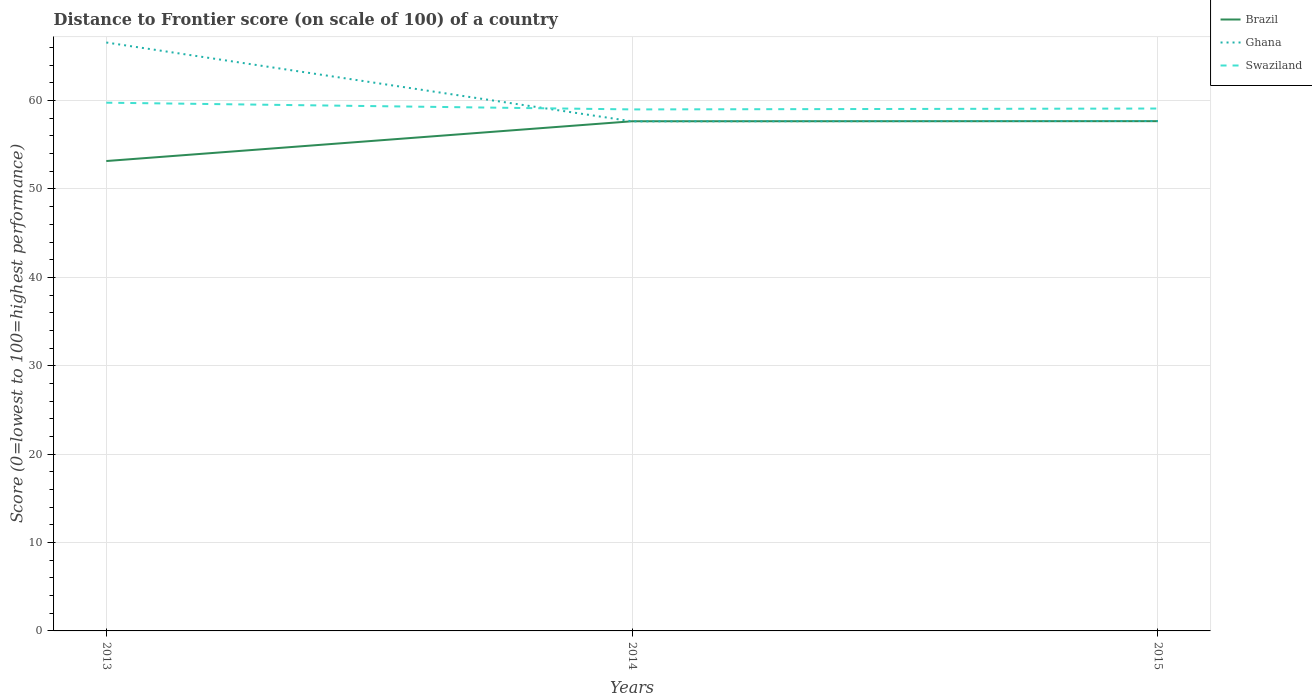How many different coloured lines are there?
Ensure brevity in your answer.  3. Does the line corresponding to Ghana intersect with the line corresponding to Swaziland?
Offer a very short reply. Yes. Is the number of lines equal to the number of legend labels?
Provide a succinct answer. Yes. Across all years, what is the maximum distance to frontier score of in Ghana?
Provide a short and direct response. 57.65. In which year was the distance to frontier score of in Brazil maximum?
Your answer should be compact. 2013. What is the total distance to frontier score of in Swaziland in the graph?
Your answer should be compact. -0.1. What is the difference between the highest and the second highest distance to frontier score of in Ghana?
Ensure brevity in your answer.  8.92. How many years are there in the graph?
Give a very brief answer. 3. Are the values on the major ticks of Y-axis written in scientific E-notation?
Make the answer very short. No. Does the graph contain any zero values?
Provide a succinct answer. No. How many legend labels are there?
Make the answer very short. 3. What is the title of the graph?
Keep it short and to the point. Distance to Frontier score (on scale of 100) of a country. What is the label or title of the X-axis?
Keep it short and to the point. Years. What is the label or title of the Y-axis?
Offer a terse response. Score (0=lowest to 100=highest performance). What is the Score (0=lowest to 100=highest performance) in Brazil in 2013?
Offer a very short reply. 53.16. What is the Score (0=lowest to 100=highest performance) in Ghana in 2013?
Your answer should be very brief. 66.57. What is the Score (0=lowest to 100=highest performance) in Swaziland in 2013?
Offer a terse response. 59.76. What is the Score (0=lowest to 100=highest performance) in Brazil in 2014?
Ensure brevity in your answer.  57.66. What is the Score (0=lowest to 100=highest performance) in Ghana in 2014?
Give a very brief answer. 57.65. What is the Score (0=lowest to 100=highest performance) in Swaziland in 2014?
Provide a succinct answer. 59. What is the Score (0=lowest to 100=highest performance) in Brazil in 2015?
Give a very brief answer. 57.67. What is the Score (0=lowest to 100=highest performance) of Ghana in 2015?
Your response must be concise. 57.69. What is the Score (0=lowest to 100=highest performance) of Swaziland in 2015?
Provide a succinct answer. 59.1. Across all years, what is the maximum Score (0=lowest to 100=highest performance) in Brazil?
Keep it short and to the point. 57.67. Across all years, what is the maximum Score (0=lowest to 100=highest performance) of Ghana?
Offer a very short reply. 66.57. Across all years, what is the maximum Score (0=lowest to 100=highest performance) of Swaziland?
Give a very brief answer. 59.76. Across all years, what is the minimum Score (0=lowest to 100=highest performance) in Brazil?
Your response must be concise. 53.16. Across all years, what is the minimum Score (0=lowest to 100=highest performance) of Ghana?
Make the answer very short. 57.65. Across all years, what is the minimum Score (0=lowest to 100=highest performance) of Swaziland?
Offer a terse response. 59. What is the total Score (0=lowest to 100=highest performance) in Brazil in the graph?
Your answer should be very brief. 168.49. What is the total Score (0=lowest to 100=highest performance) of Ghana in the graph?
Your answer should be very brief. 181.91. What is the total Score (0=lowest to 100=highest performance) of Swaziland in the graph?
Your answer should be compact. 177.86. What is the difference between the Score (0=lowest to 100=highest performance) of Brazil in 2013 and that in 2014?
Provide a succinct answer. -4.5. What is the difference between the Score (0=lowest to 100=highest performance) in Ghana in 2013 and that in 2014?
Your response must be concise. 8.92. What is the difference between the Score (0=lowest to 100=highest performance) in Swaziland in 2013 and that in 2014?
Provide a succinct answer. 0.76. What is the difference between the Score (0=lowest to 100=highest performance) in Brazil in 2013 and that in 2015?
Provide a succinct answer. -4.51. What is the difference between the Score (0=lowest to 100=highest performance) of Ghana in 2013 and that in 2015?
Make the answer very short. 8.88. What is the difference between the Score (0=lowest to 100=highest performance) of Swaziland in 2013 and that in 2015?
Offer a terse response. 0.66. What is the difference between the Score (0=lowest to 100=highest performance) of Brazil in 2014 and that in 2015?
Provide a succinct answer. -0.01. What is the difference between the Score (0=lowest to 100=highest performance) of Ghana in 2014 and that in 2015?
Your answer should be compact. -0.04. What is the difference between the Score (0=lowest to 100=highest performance) of Swaziland in 2014 and that in 2015?
Give a very brief answer. -0.1. What is the difference between the Score (0=lowest to 100=highest performance) of Brazil in 2013 and the Score (0=lowest to 100=highest performance) of Ghana in 2014?
Give a very brief answer. -4.49. What is the difference between the Score (0=lowest to 100=highest performance) in Brazil in 2013 and the Score (0=lowest to 100=highest performance) in Swaziland in 2014?
Your response must be concise. -5.84. What is the difference between the Score (0=lowest to 100=highest performance) in Ghana in 2013 and the Score (0=lowest to 100=highest performance) in Swaziland in 2014?
Your answer should be very brief. 7.57. What is the difference between the Score (0=lowest to 100=highest performance) in Brazil in 2013 and the Score (0=lowest to 100=highest performance) in Ghana in 2015?
Give a very brief answer. -4.53. What is the difference between the Score (0=lowest to 100=highest performance) of Brazil in 2013 and the Score (0=lowest to 100=highest performance) of Swaziland in 2015?
Keep it short and to the point. -5.94. What is the difference between the Score (0=lowest to 100=highest performance) in Ghana in 2013 and the Score (0=lowest to 100=highest performance) in Swaziland in 2015?
Provide a short and direct response. 7.47. What is the difference between the Score (0=lowest to 100=highest performance) in Brazil in 2014 and the Score (0=lowest to 100=highest performance) in Ghana in 2015?
Your answer should be very brief. -0.03. What is the difference between the Score (0=lowest to 100=highest performance) in Brazil in 2014 and the Score (0=lowest to 100=highest performance) in Swaziland in 2015?
Your response must be concise. -1.44. What is the difference between the Score (0=lowest to 100=highest performance) of Ghana in 2014 and the Score (0=lowest to 100=highest performance) of Swaziland in 2015?
Ensure brevity in your answer.  -1.45. What is the average Score (0=lowest to 100=highest performance) of Brazil per year?
Give a very brief answer. 56.16. What is the average Score (0=lowest to 100=highest performance) in Ghana per year?
Make the answer very short. 60.64. What is the average Score (0=lowest to 100=highest performance) of Swaziland per year?
Your answer should be very brief. 59.29. In the year 2013, what is the difference between the Score (0=lowest to 100=highest performance) of Brazil and Score (0=lowest to 100=highest performance) of Ghana?
Your answer should be compact. -13.41. In the year 2013, what is the difference between the Score (0=lowest to 100=highest performance) of Ghana and Score (0=lowest to 100=highest performance) of Swaziland?
Your answer should be compact. 6.81. In the year 2014, what is the difference between the Score (0=lowest to 100=highest performance) in Brazil and Score (0=lowest to 100=highest performance) in Swaziland?
Provide a succinct answer. -1.34. In the year 2014, what is the difference between the Score (0=lowest to 100=highest performance) of Ghana and Score (0=lowest to 100=highest performance) of Swaziland?
Make the answer very short. -1.35. In the year 2015, what is the difference between the Score (0=lowest to 100=highest performance) in Brazil and Score (0=lowest to 100=highest performance) in Ghana?
Provide a short and direct response. -0.02. In the year 2015, what is the difference between the Score (0=lowest to 100=highest performance) of Brazil and Score (0=lowest to 100=highest performance) of Swaziland?
Your answer should be compact. -1.43. In the year 2015, what is the difference between the Score (0=lowest to 100=highest performance) of Ghana and Score (0=lowest to 100=highest performance) of Swaziland?
Provide a short and direct response. -1.41. What is the ratio of the Score (0=lowest to 100=highest performance) in Brazil in 2013 to that in 2014?
Make the answer very short. 0.92. What is the ratio of the Score (0=lowest to 100=highest performance) of Ghana in 2013 to that in 2014?
Your answer should be compact. 1.15. What is the ratio of the Score (0=lowest to 100=highest performance) in Swaziland in 2013 to that in 2014?
Make the answer very short. 1.01. What is the ratio of the Score (0=lowest to 100=highest performance) in Brazil in 2013 to that in 2015?
Ensure brevity in your answer.  0.92. What is the ratio of the Score (0=lowest to 100=highest performance) of Ghana in 2013 to that in 2015?
Give a very brief answer. 1.15. What is the ratio of the Score (0=lowest to 100=highest performance) in Swaziland in 2013 to that in 2015?
Make the answer very short. 1.01. What is the difference between the highest and the second highest Score (0=lowest to 100=highest performance) of Brazil?
Your response must be concise. 0.01. What is the difference between the highest and the second highest Score (0=lowest to 100=highest performance) of Ghana?
Your answer should be compact. 8.88. What is the difference between the highest and the second highest Score (0=lowest to 100=highest performance) in Swaziland?
Provide a short and direct response. 0.66. What is the difference between the highest and the lowest Score (0=lowest to 100=highest performance) of Brazil?
Provide a succinct answer. 4.51. What is the difference between the highest and the lowest Score (0=lowest to 100=highest performance) in Ghana?
Keep it short and to the point. 8.92. What is the difference between the highest and the lowest Score (0=lowest to 100=highest performance) of Swaziland?
Provide a short and direct response. 0.76. 